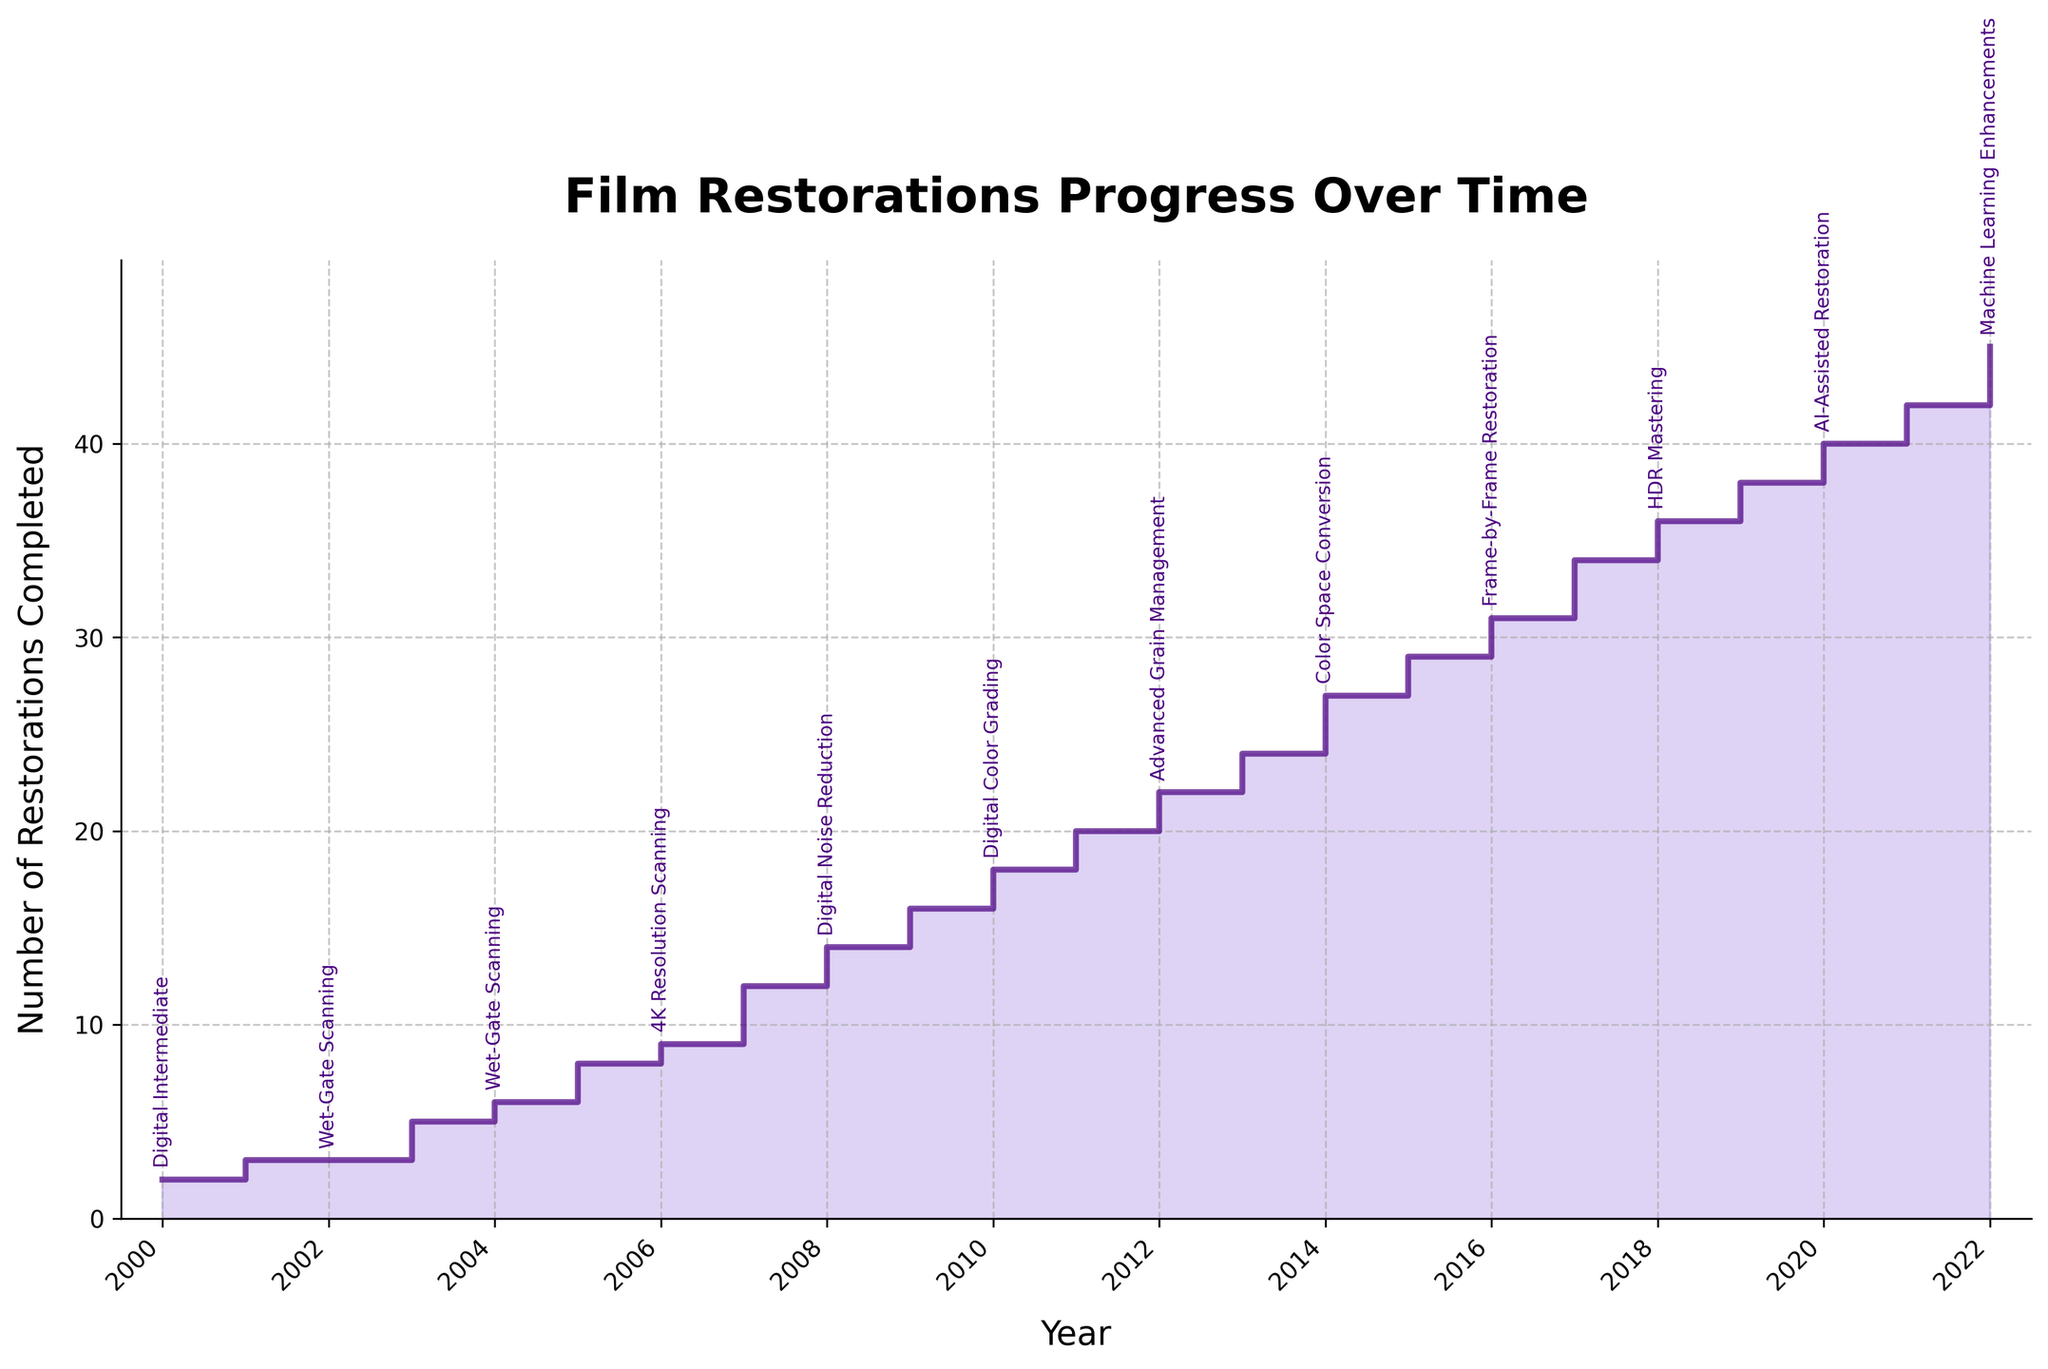what is the title of the plot? The title of the plot is typically found at the top and it summarizes the chart's purpose. Here, "Film Restorations Progress Over Time" is displayed at the top, indicating the plot's focus.
Answer: Film Restorations Progress Over Time What is the number of restorations completed in 2010? The number of restorations completed can be read from the Y-axis at the point corresponding to the year 2010 on the X-axis. The plot shows 18 restorations for that year.
Answer: 18 What technological improvement was introduced in 2008? Each technological improvement is annotated next to the corresponding year on the plot. For 2008, the plot indicates "Digital Noise Reduction" as the technology introduced.
Answer: Digital Noise Reduction What years saw an introduction of a new technology every consecutive year? Checking the annotations in the plot, new technologies were introduced consecutively in 2018, 2019, 2020, and 2021: "HDR Mastering," "AI-Assisted Restoration," "Machine Learning Enhancements."
Answer: 2018, 2019, 2020, 2021 How many restorations were completed in 2004 and how many more were completed in 2009? From the plot, 6 restorations were completed in 2004 and 16 in 2009. The difference is 16 - 6 = 10 restorations.
Answer: 10 What year had the highest number of restorations completed, and how many were there? By observing the stair plot, the year 2022 had the highest number of restorations completed, which is 45 restorations.
Answer: 2022, 45 How much did the number of restorations change from 2002 to 2003? The plot shows 3 restorations in 2002 and 5 in 2003. The change is 5 - 3 = 2 restorations.
Answer: 2 Which technological improvement corresponds to the largest visible increase in restorations? From analyzing the jumps between steps visually, the most significant increase happens between 2004 and 2005 (from 6 to 8), where "4K Resolution Scanning" had been introduced. Following this period also shows consistent growth in restorations completed.
Answer: 4K Resolution Scanning 